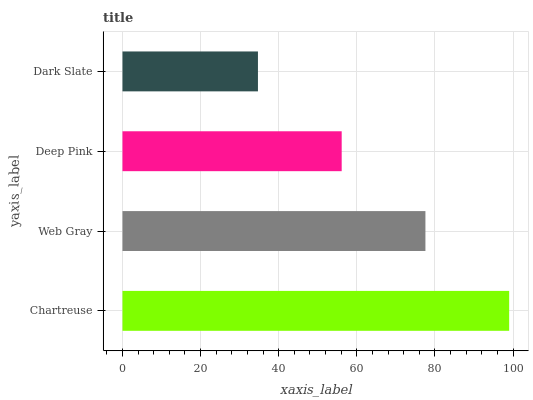Is Dark Slate the minimum?
Answer yes or no. Yes. Is Chartreuse the maximum?
Answer yes or no. Yes. Is Web Gray the minimum?
Answer yes or no. No. Is Web Gray the maximum?
Answer yes or no. No. Is Chartreuse greater than Web Gray?
Answer yes or no. Yes. Is Web Gray less than Chartreuse?
Answer yes or no. Yes. Is Web Gray greater than Chartreuse?
Answer yes or no. No. Is Chartreuse less than Web Gray?
Answer yes or no. No. Is Web Gray the high median?
Answer yes or no. Yes. Is Deep Pink the low median?
Answer yes or no. Yes. Is Dark Slate the high median?
Answer yes or no. No. Is Dark Slate the low median?
Answer yes or no. No. 